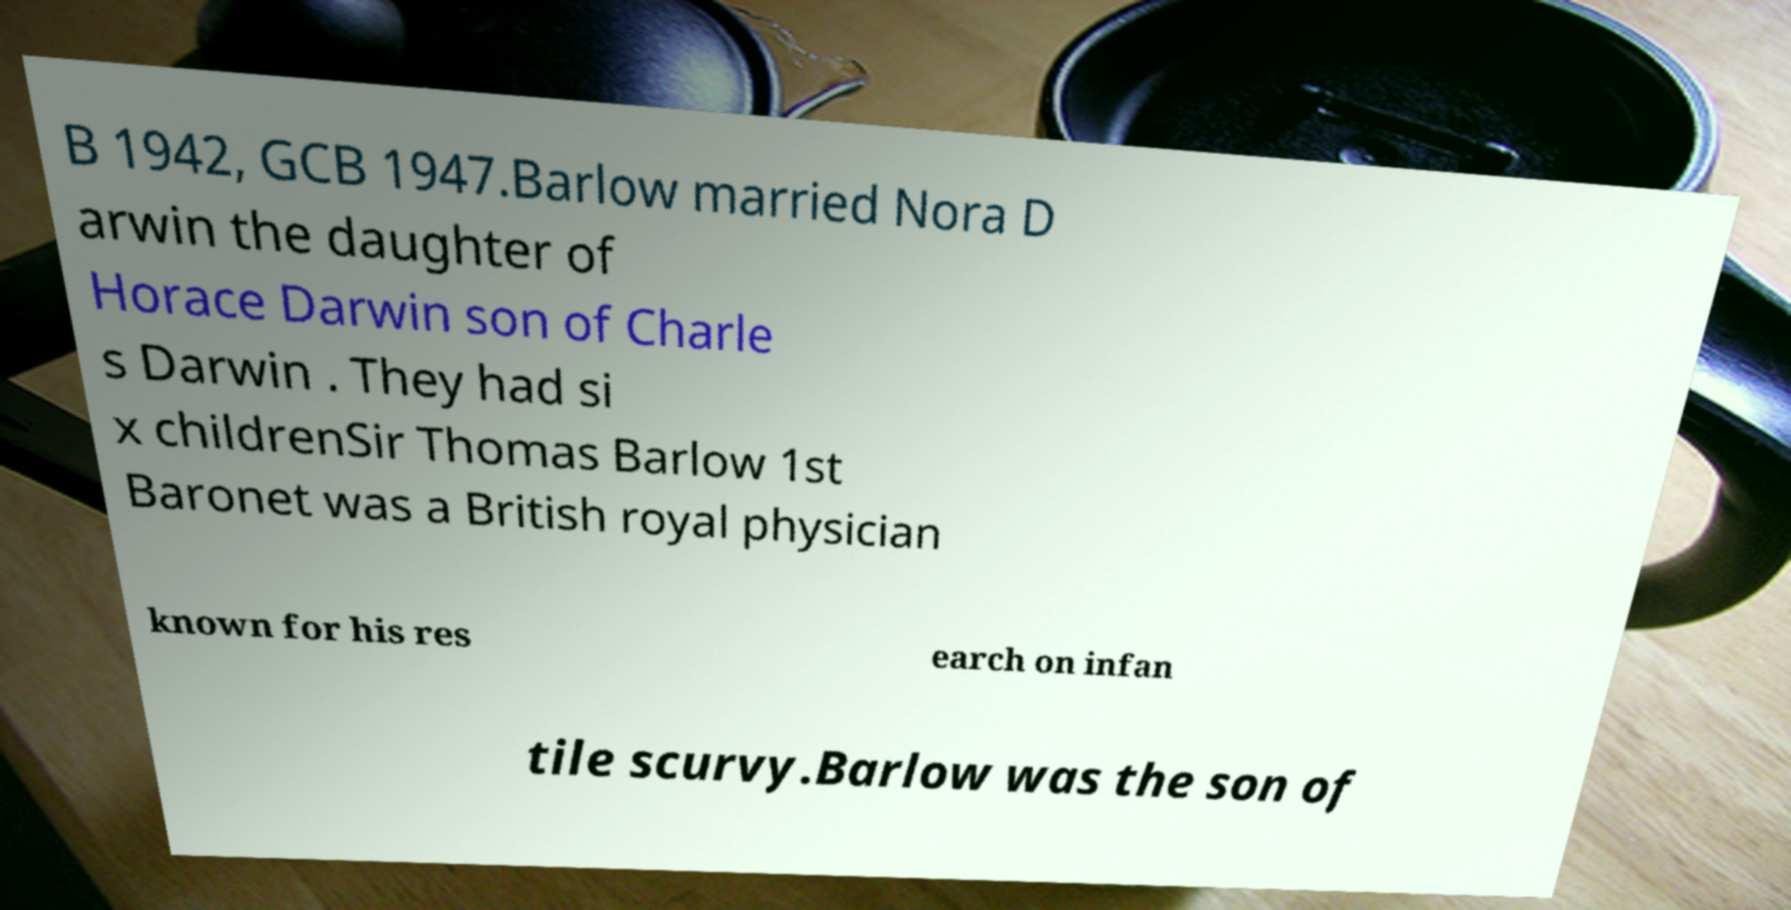There's text embedded in this image that I need extracted. Can you transcribe it verbatim? B 1942, GCB 1947.Barlow married Nora D arwin the daughter of Horace Darwin son of Charle s Darwin . They had si x childrenSir Thomas Barlow 1st Baronet was a British royal physician known for his res earch on infan tile scurvy.Barlow was the son of 